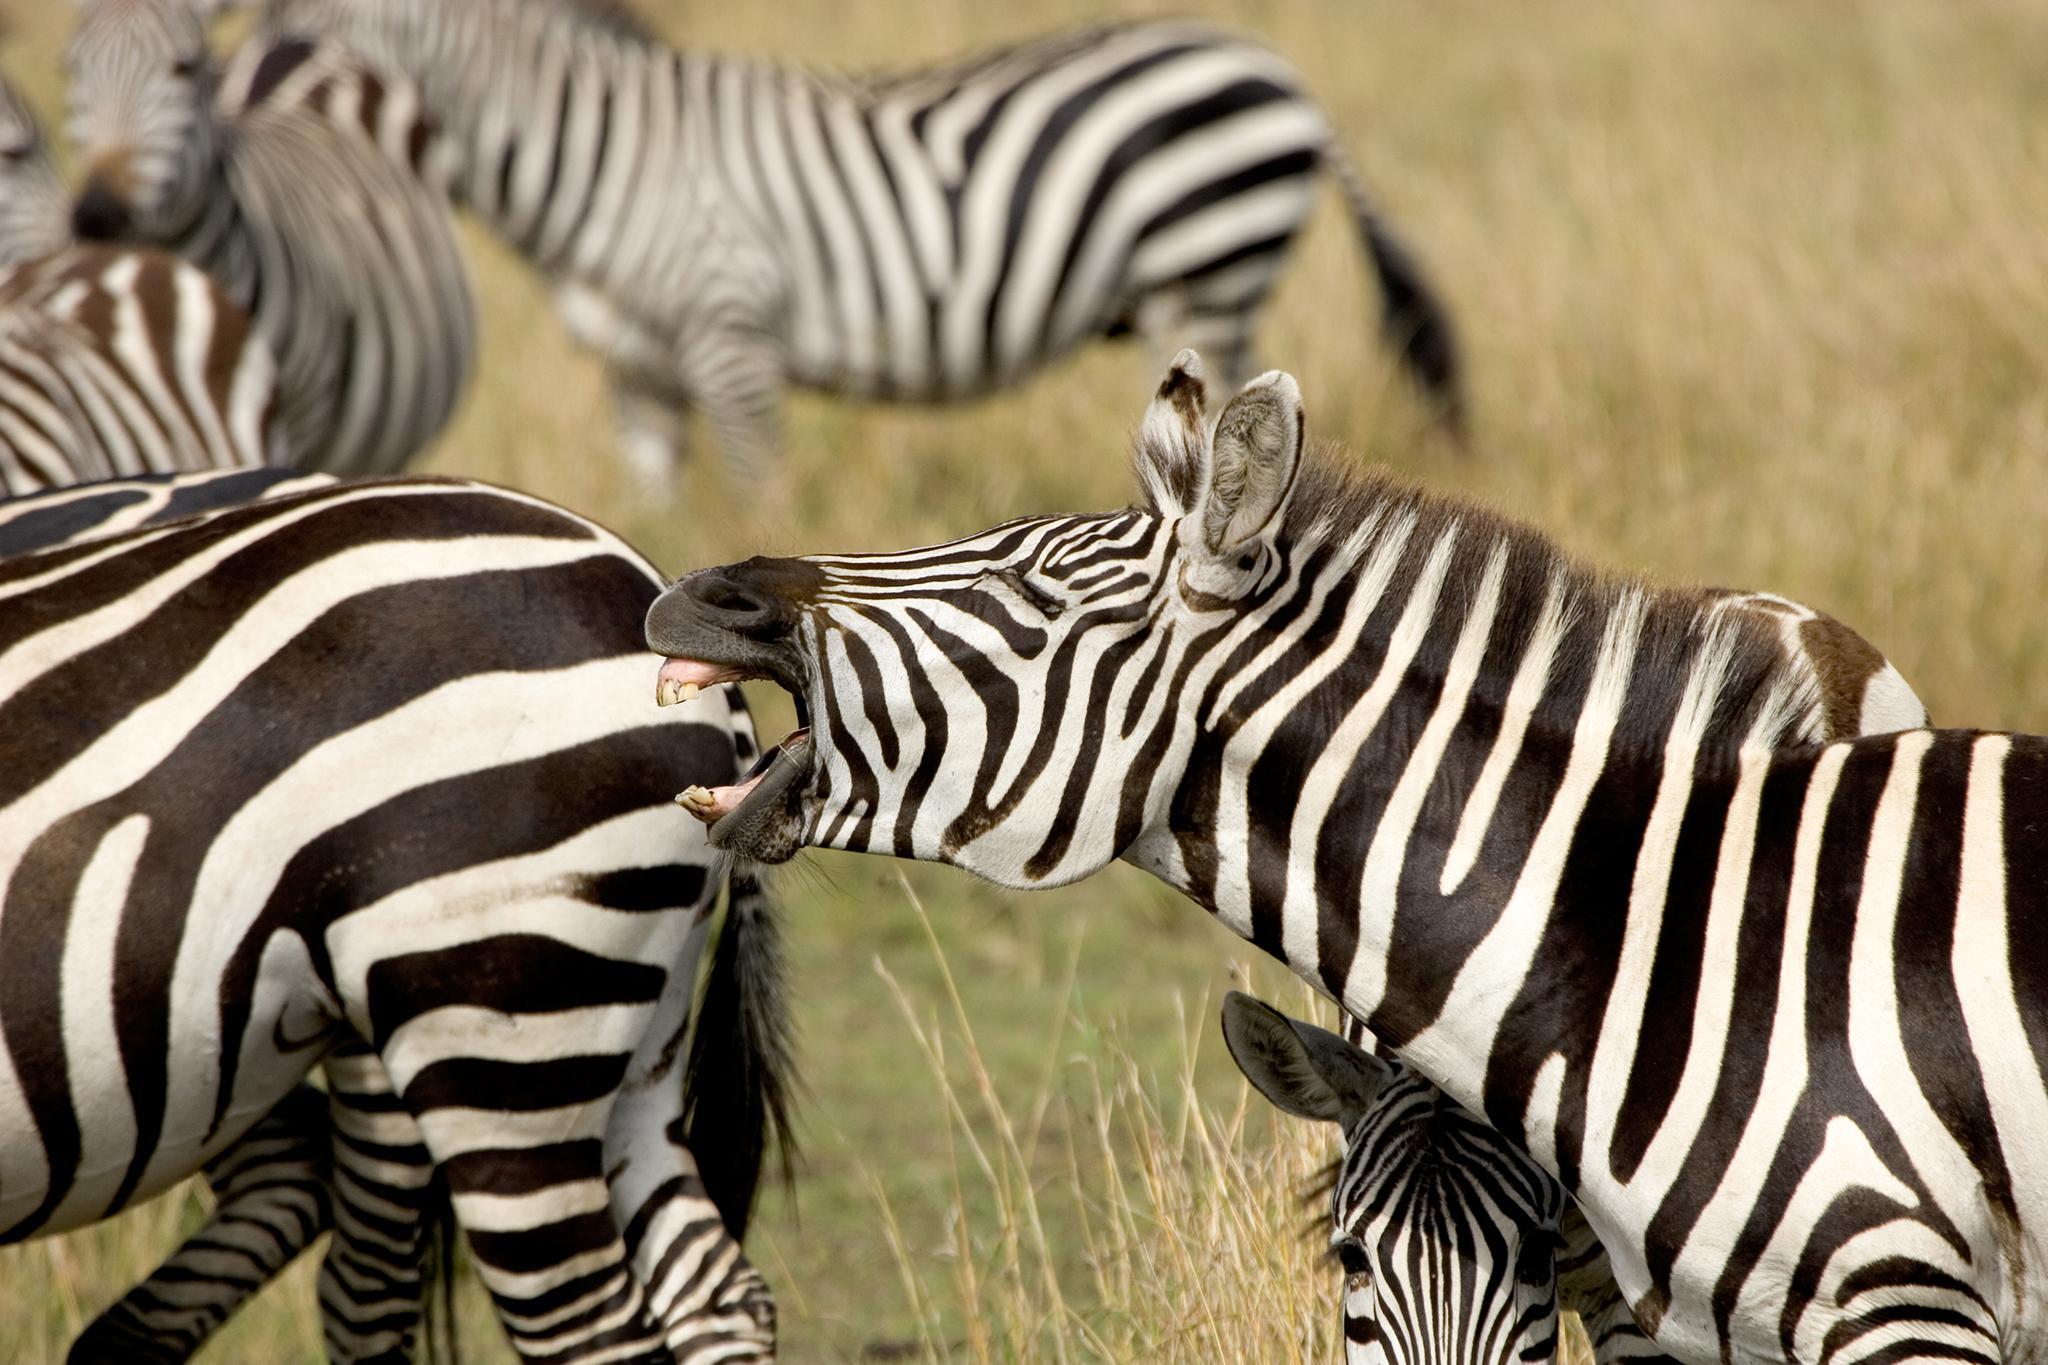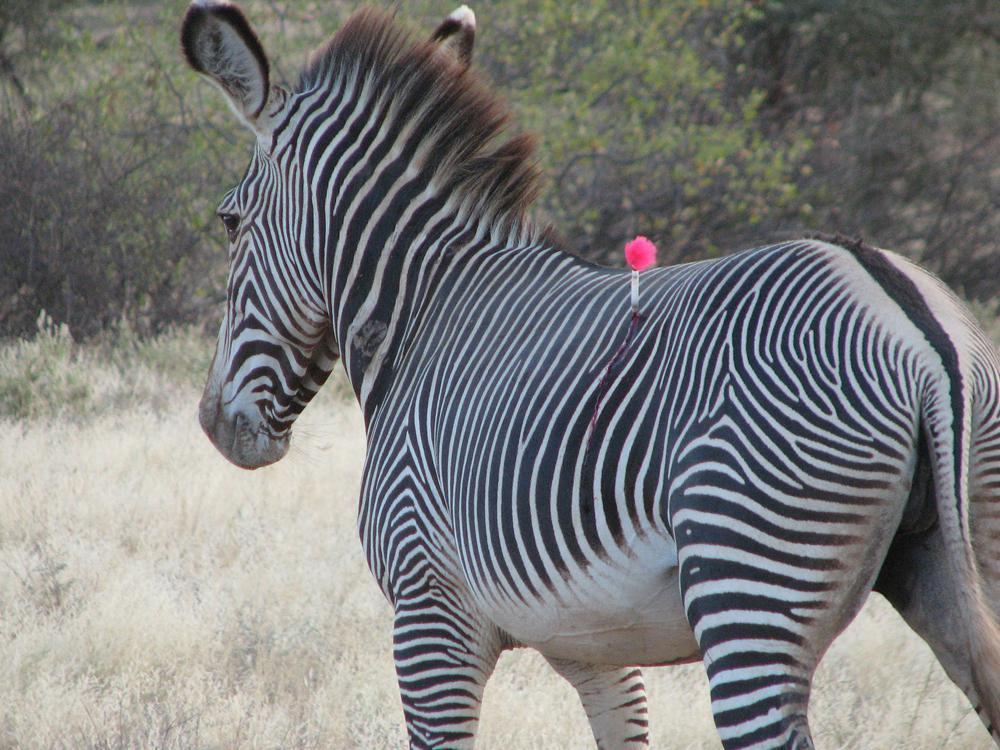The first image is the image on the left, the second image is the image on the right. Assess this claim about the two images: "One image shows a mass of rightward-facing zebras with no space visible between any of them.". Correct or not? Answer yes or no. No. The first image is the image on the left, the second image is the image on the right. Given the left and right images, does the statement "There are two to three zebra facing left moving forward." hold true? Answer yes or no. Yes. 